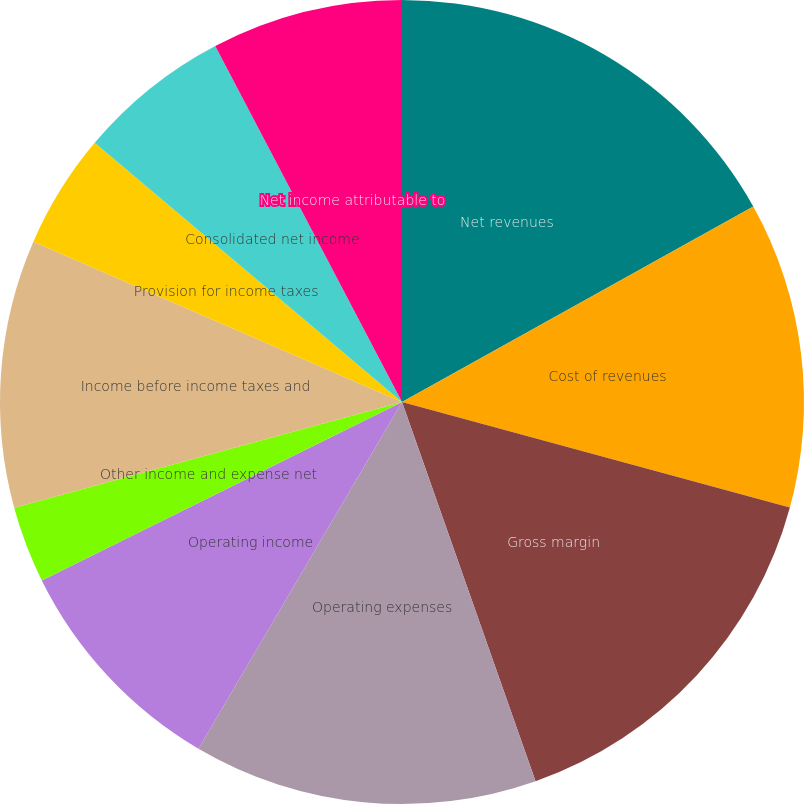<chart> <loc_0><loc_0><loc_500><loc_500><pie_chart><fcel>Net revenues<fcel>Cost of revenues<fcel>Gross margin<fcel>Operating expenses<fcel>Operating income<fcel>Other income and expense net<fcel>Income before income taxes and<fcel>Provision for income taxes<fcel>Consolidated net income<fcel>Net income attributable to<nl><fcel>16.92%<fcel>12.31%<fcel>15.38%<fcel>13.84%<fcel>9.23%<fcel>3.08%<fcel>10.77%<fcel>4.62%<fcel>6.16%<fcel>7.69%<nl></chart> 